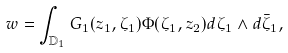<formula> <loc_0><loc_0><loc_500><loc_500>w = \int _ { \mathbb { D } _ { 1 } } G _ { 1 } ( z _ { 1 } , \zeta _ { 1 } ) \Phi ( \zeta _ { 1 } , z _ { 2 } ) d \zeta _ { 1 } \wedge d \bar { \zeta } _ { 1 } ,</formula> 